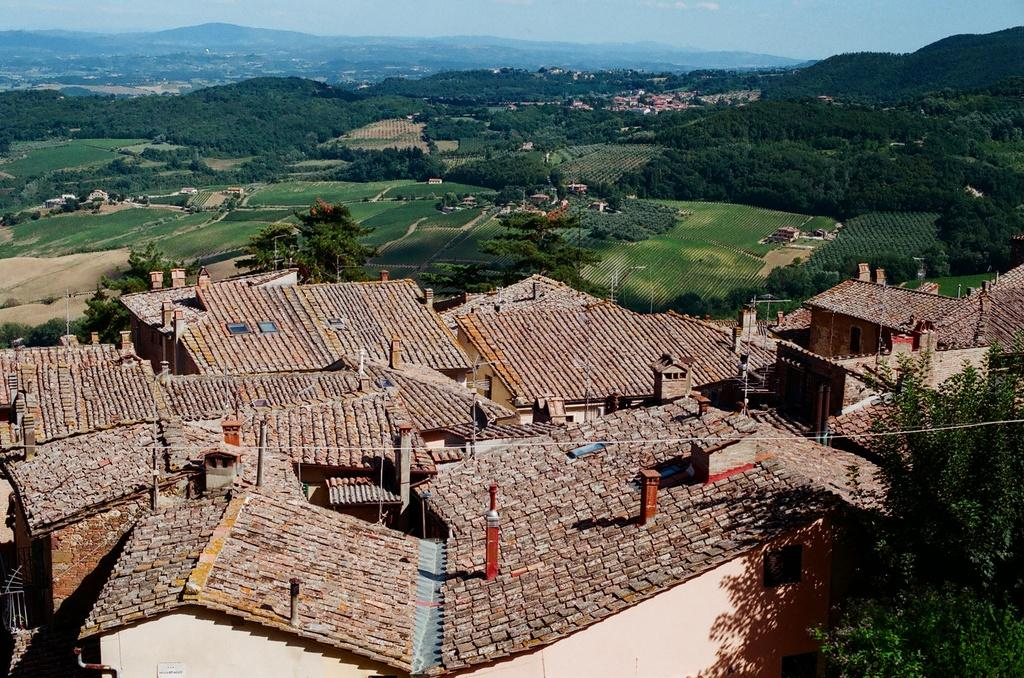What type of structures can be seen in the foreground of the image? There are buildings in the foreground of the image. What is located on the right side of the image? There is a tree on the right side of the image. What can be seen in the background of the image? There are trees, buildings, hills, and the sky visible in the background of the image. What type of behavior can be observed in the iron in the image? There is no iron present in the image, so it is not possible to observe any behavior related to it. 